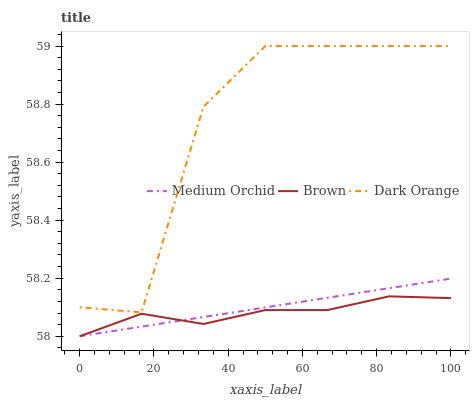Does Brown have the minimum area under the curve?
Answer yes or no. Yes. Does Dark Orange have the maximum area under the curve?
Answer yes or no. Yes. Does Medium Orchid have the minimum area under the curve?
Answer yes or no. No. Does Medium Orchid have the maximum area under the curve?
Answer yes or no. No. Is Medium Orchid the smoothest?
Answer yes or no. Yes. Is Dark Orange the roughest?
Answer yes or no. Yes. Is Dark Orange the smoothest?
Answer yes or no. No. Is Medium Orchid the roughest?
Answer yes or no. No. Does Dark Orange have the lowest value?
Answer yes or no. No. Does Medium Orchid have the highest value?
Answer yes or no. No. Is Brown less than Dark Orange?
Answer yes or no. Yes. Is Dark Orange greater than Medium Orchid?
Answer yes or no. Yes. Does Brown intersect Dark Orange?
Answer yes or no. No. 